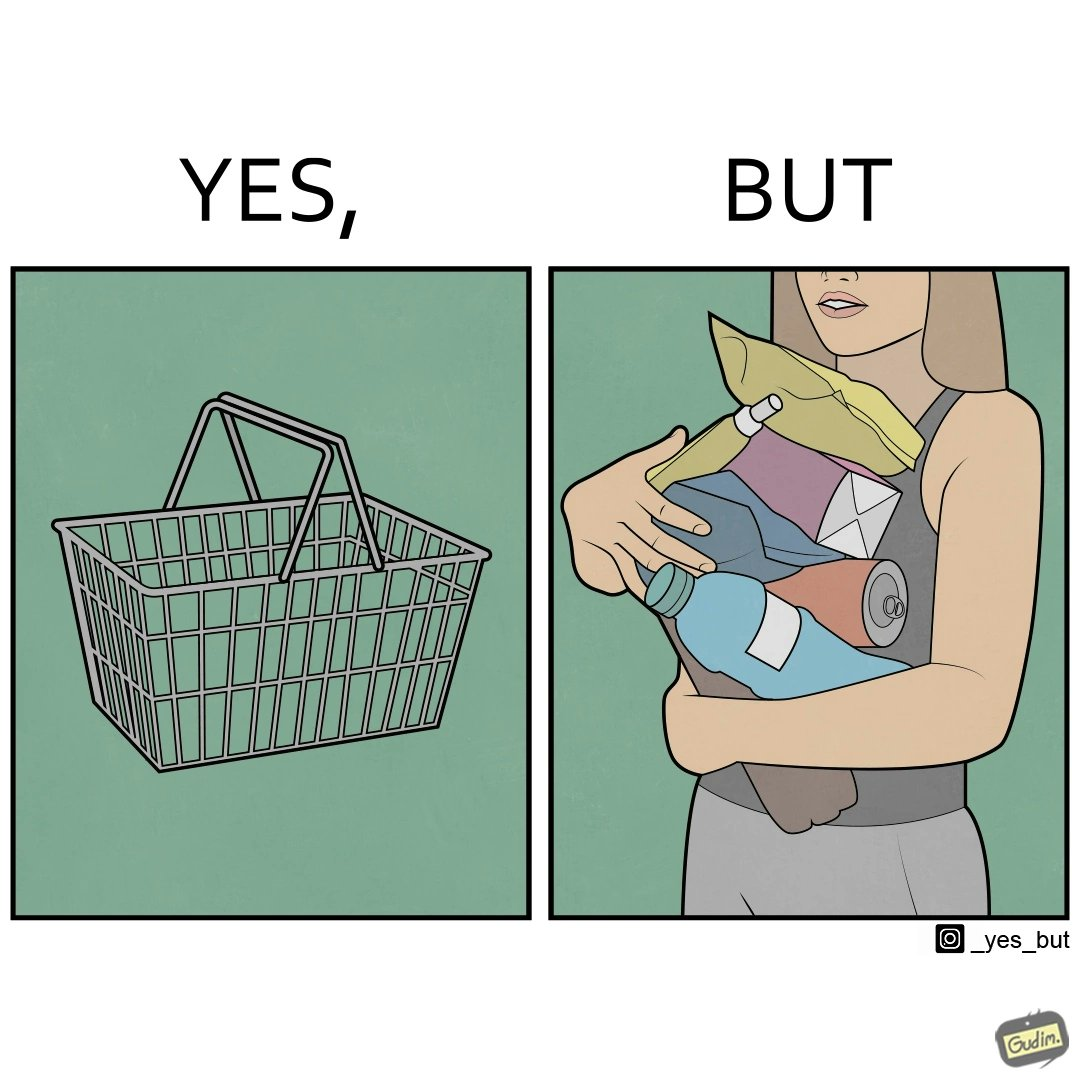Does this image contain satire or humor? Yes, this image is satirical. 